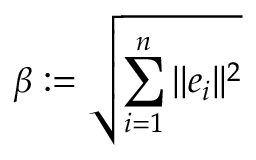Convert formula to latex. <formula><loc_0><loc_0><loc_500><loc_500>\beta \colon = { \sqrt { \sum _ { i = 1 } ^ { n } | | e _ { i } | | ^ { 2 } } }</formula> 